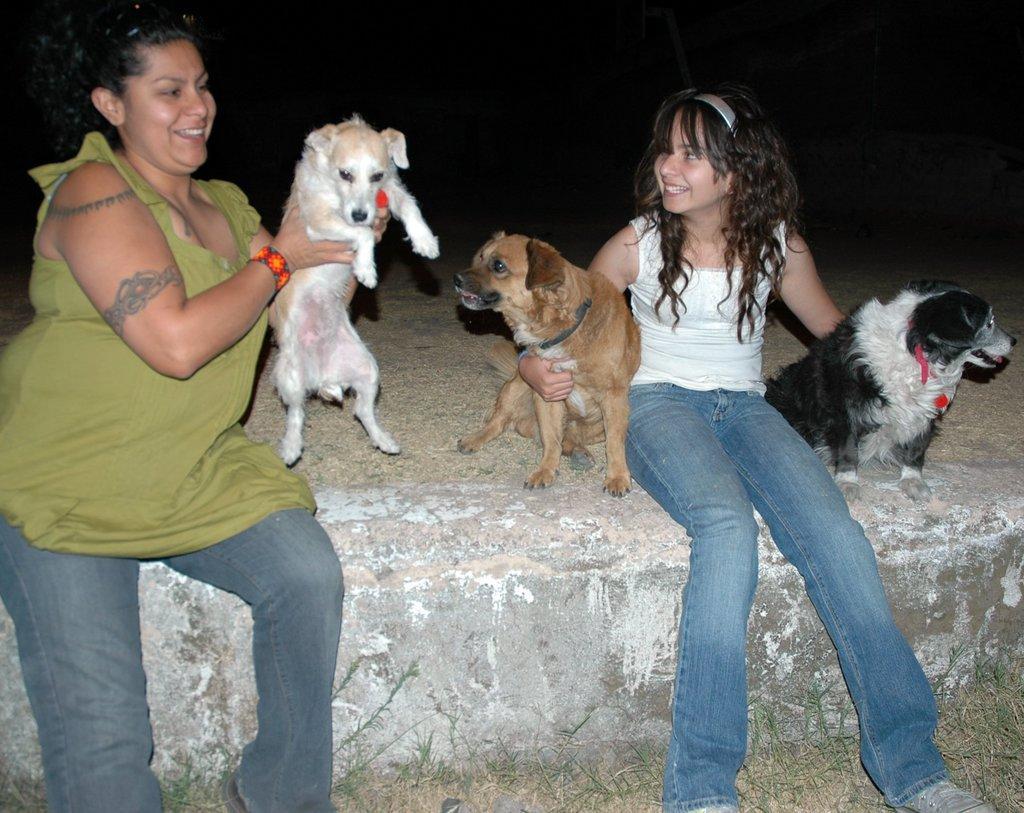In one or two sentences, can you explain what this image depicts? In this picture I can see a woman and a girl holding dogs and I can see dark background and grass on the ground. 